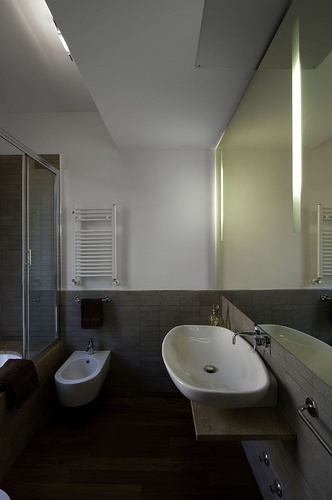Describe the objects in this image and their specific colors. I can see sink in gray, darkgray, and black tones and toilet in gray and black tones in this image. 